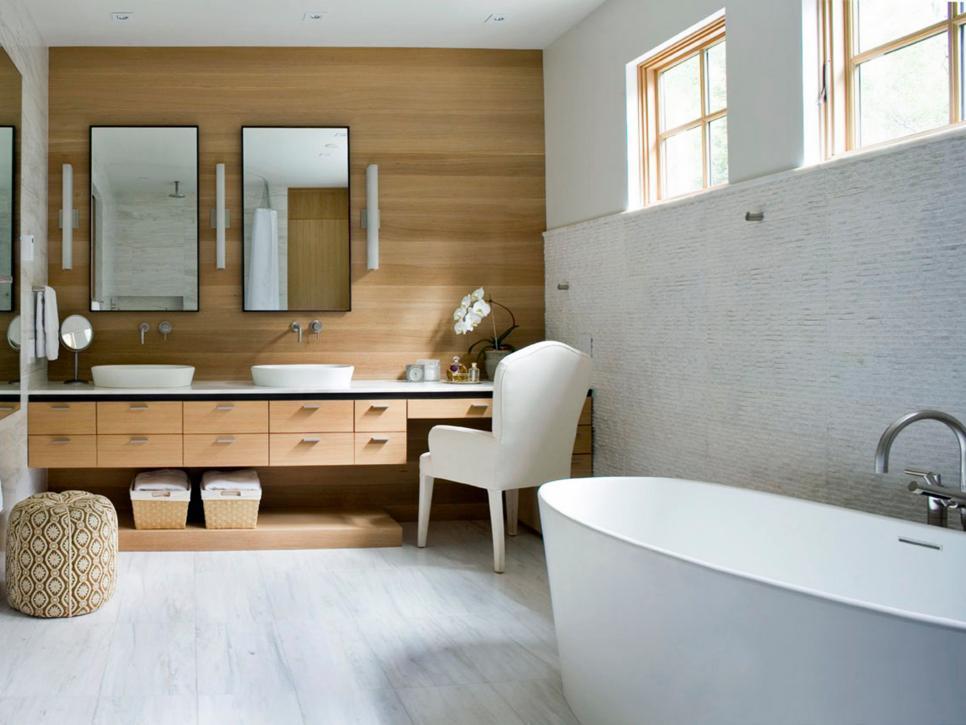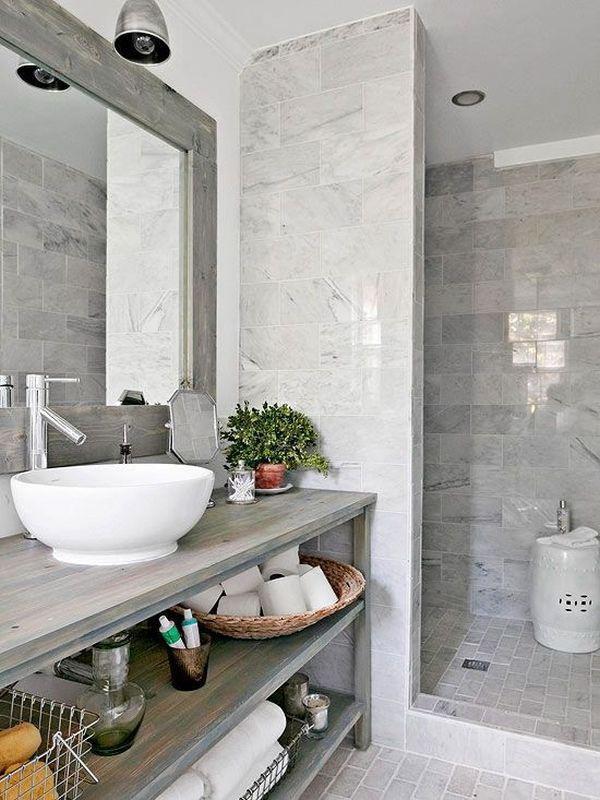The first image is the image on the left, the second image is the image on the right. For the images displayed, is the sentence "There is exactly one sink." factually correct? Answer yes or no. No. The first image is the image on the left, the second image is the image on the right. Considering the images on both sides, is "Three or more sinks are visible." valid? Answer yes or no. Yes. 